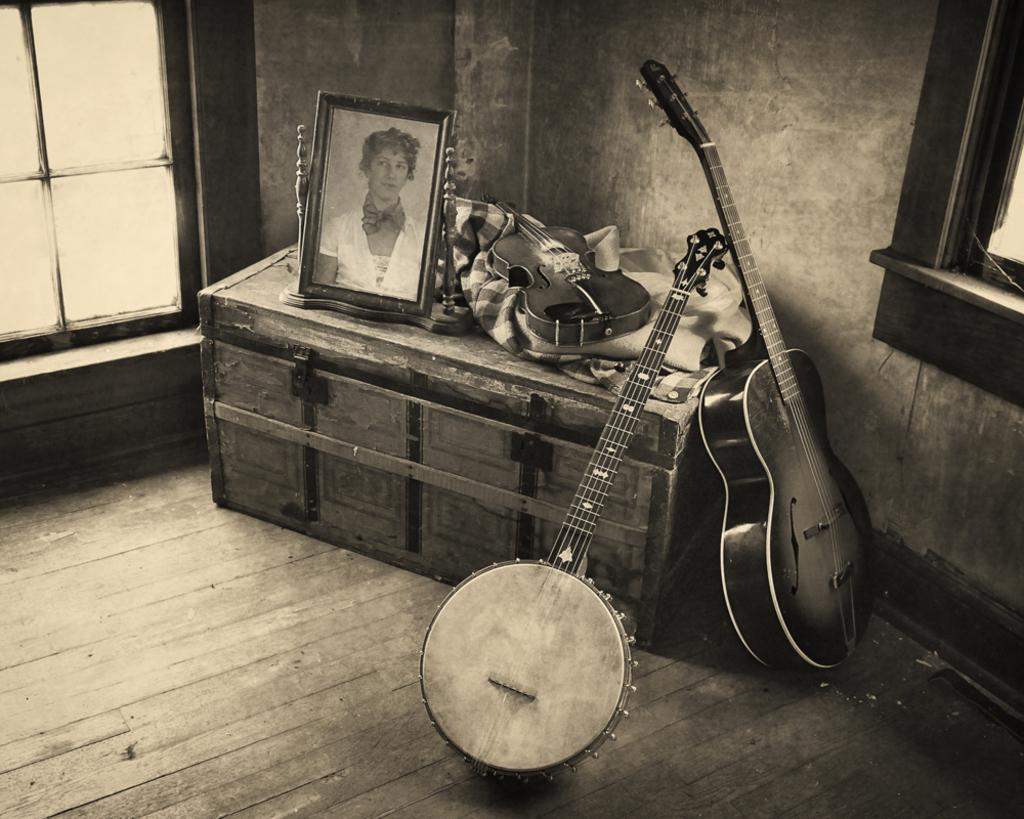What is the color scheme of the image? The image is black and white. What object can be seen in the image? There is a box in the image. What is on top of the box? A cloth and a guitar are on the box. What is depicted on the box? There is a picture of a woman on the box. Are there any other guitars visible in the image? Yes, there are guitars beside the box. What architectural feature can be seen in the image? There is a window in the image. What type of jeans is the woman wearing in the image? There is no woman visible in the image, and therefore no clothing can be observed. What sound does the bell make in the image? There is no bell present in the image. 